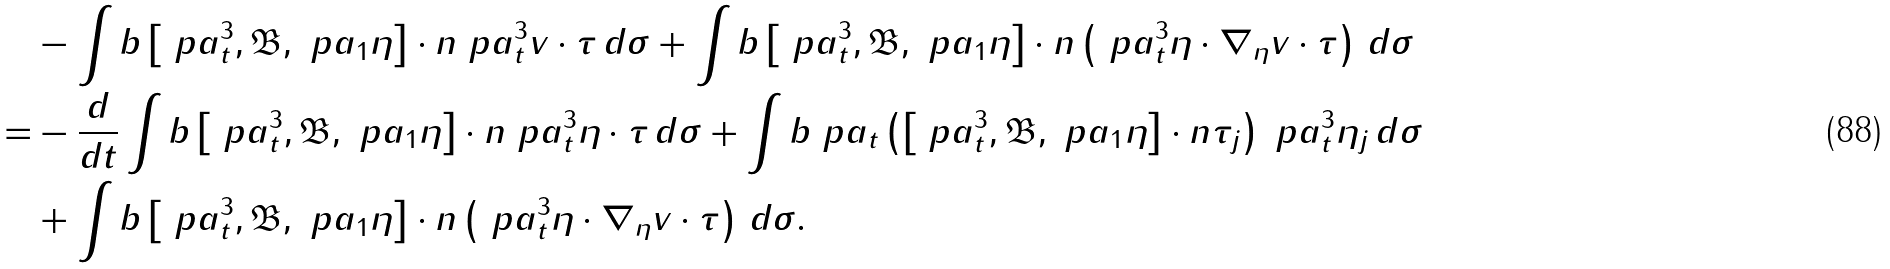<formula> <loc_0><loc_0><loc_500><loc_500>& - \int b \left [ \ p a _ { t } ^ { 3 } , \mathfrak B , \ p a _ { 1 } \eta \right ] \cdot n \ p a _ { t } ^ { 3 } v \cdot \tau \, d \sigma + \int b \left [ \ p a _ { t } ^ { 3 } , \mathfrak B , \ p a _ { 1 } \eta \right ] \cdot n \left ( \ p a _ { t } ^ { 3 } \eta \cdot \nabla _ { \eta } v \cdot \tau \right ) \, d \sigma \\ = & - \frac { d } { d t } \int b \left [ \ p a _ { t } ^ { 3 } , \mathfrak B , \ p a _ { 1 } \eta \right ] \cdot n \ p a _ { t } ^ { 3 } \eta \cdot \tau \, d \sigma + \int b \ p a _ { t } \left ( \left [ \ p a _ { t } ^ { 3 } , \mathfrak B , \ p a _ { 1 } \eta \right ] \cdot n \tau _ { j } \right ) \ p a _ { t } ^ { 3 } \eta _ { j } \, d \sigma \\ & + \int b \left [ \ p a _ { t } ^ { 3 } , \mathfrak B , \ p a _ { 1 } \eta \right ] \cdot n \left ( \ p a _ { t } ^ { 3 } \eta \cdot \nabla _ { \eta } v \cdot \tau \right ) \, d \sigma .</formula> 